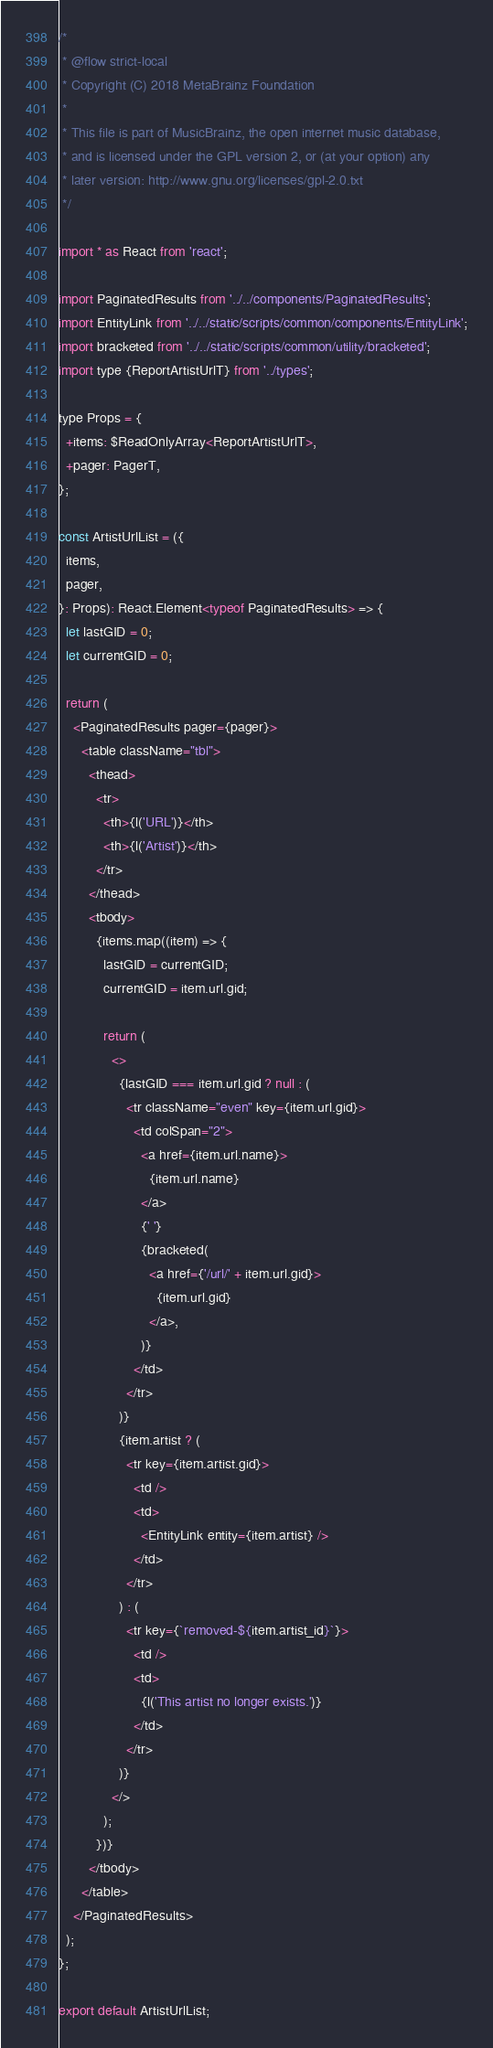<code> <loc_0><loc_0><loc_500><loc_500><_JavaScript_>/*
 * @flow strict-local
 * Copyright (C) 2018 MetaBrainz Foundation
 *
 * This file is part of MusicBrainz, the open internet music database,
 * and is licensed under the GPL version 2, or (at your option) any
 * later version: http://www.gnu.org/licenses/gpl-2.0.txt
 */

import * as React from 'react';

import PaginatedResults from '../../components/PaginatedResults';
import EntityLink from '../../static/scripts/common/components/EntityLink';
import bracketed from '../../static/scripts/common/utility/bracketed';
import type {ReportArtistUrlT} from '../types';

type Props = {
  +items: $ReadOnlyArray<ReportArtistUrlT>,
  +pager: PagerT,
};

const ArtistUrlList = ({
  items,
  pager,
}: Props): React.Element<typeof PaginatedResults> => {
  let lastGID = 0;
  let currentGID = 0;

  return (
    <PaginatedResults pager={pager}>
      <table className="tbl">
        <thead>
          <tr>
            <th>{l('URL')}</th>
            <th>{l('Artist')}</th>
          </tr>
        </thead>
        <tbody>
          {items.map((item) => {
            lastGID = currentGID;
            currentGID = item.url.gid;

            return (
              <>
                {lastGID === item.url.gid ? null : (
                  <tr className="even" key={item.url.gid}>
                    <td colSpan="2">
                      <a href={item.url.name}>
                        {item.url.name}
                      </a>
                      {' '}
                      {bracketed(
                        <a href={'/url/' + item.url.gid}>
                          {item.url.gid}
                        </a>,
                      )}
                    </td>
                  </tr>
                )}
                {item.artist ? (
                  <tr key={item.artist.gid}>
                    <td />
                    <td>
                      <EntityLink entity={item.artist} />
                    </td>
                  </tr>
                ) : (
                  <tr key={`removed-${item.artist_id}`}>
                    <td />
                    <td>
                      {l('This artist no longer exists.')}
                    </td>
                  </tr>
                )}
              </>
            );
          })}
        </tbody>
      </table>
    </PaginatedResults>
  );
};

export default ArtistUrlList;
</code> 